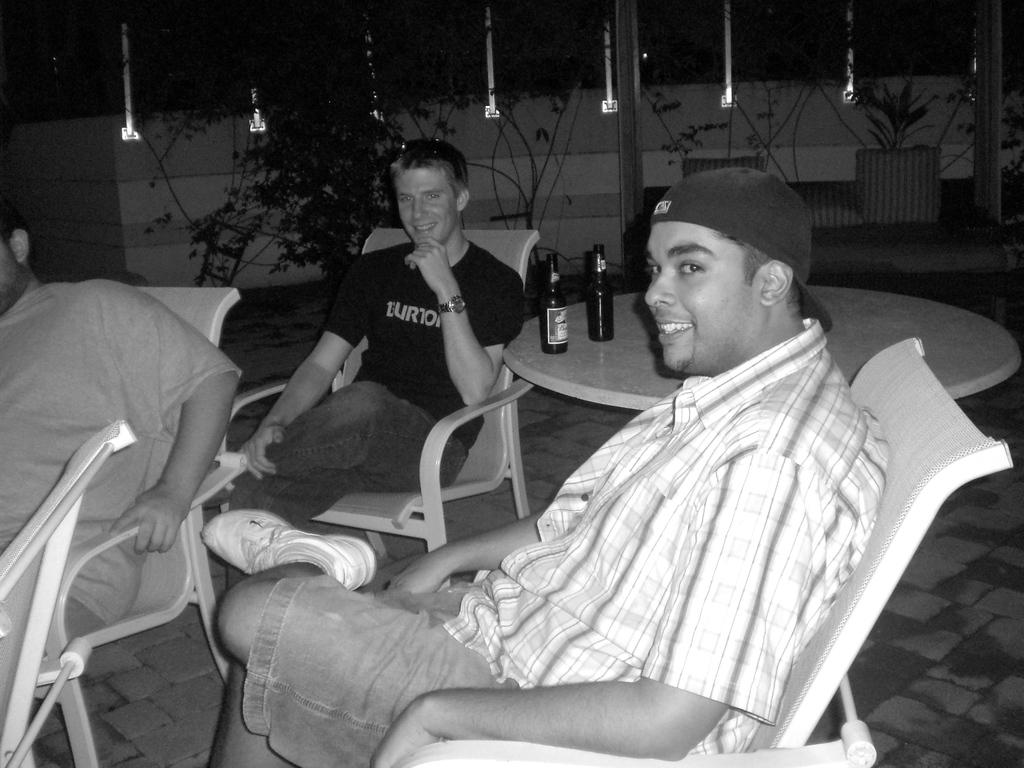How many persons are in the image? There are three persons in the image. What are the persons in the image doing? The persons are sitting on chairs. What expressions do the persons have in the image? The persons are smiling. What can be seen on the table in the image? There are wine bottles on a table in the image. What type of system is being used by the persons in the image? There is no indication in the image of a specific system being used by the persons. What trip might the persons be planning based on the image? There is no information in the image to suggest that the persons are planning a trip. 